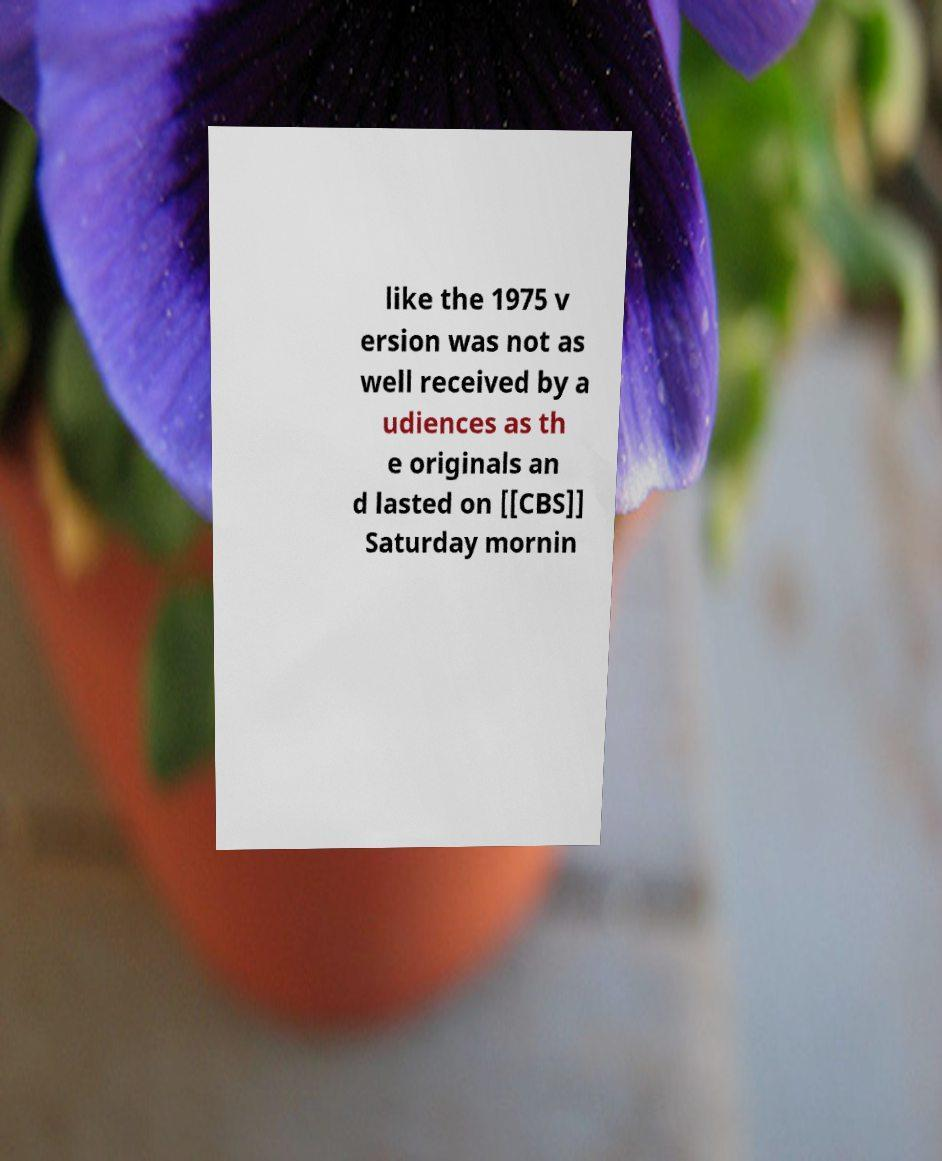Please identify and transcribe the text found in this image. like the 1975 v ersion was not as well received by a udiences as th e originals an d lasted on [[CBS]] Saturday mornin 